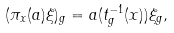Convert formula to latex. <formula><loc_0><loc_0><loc_500><loc_500>( \pi _ { x } ( a ) \xi ) _ { g } = a ( t ^ { - 1 } _ { g } ( x ) ) \xi _ { g } ,</formula> 